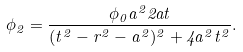Convert formula to latex. <formula><loc_0><loc_0><loc_500><loc_500>\phi _ { 2 } = \frac { \phi _ { 0 } a ^ { 2 } 2 a t } { ( t ^ { 2 } - r ^ { 2 } - a ^ { 2 } ) ^ { 2 } + 4 a ^ { 2 } t ^ { 2 } } .</formula> 